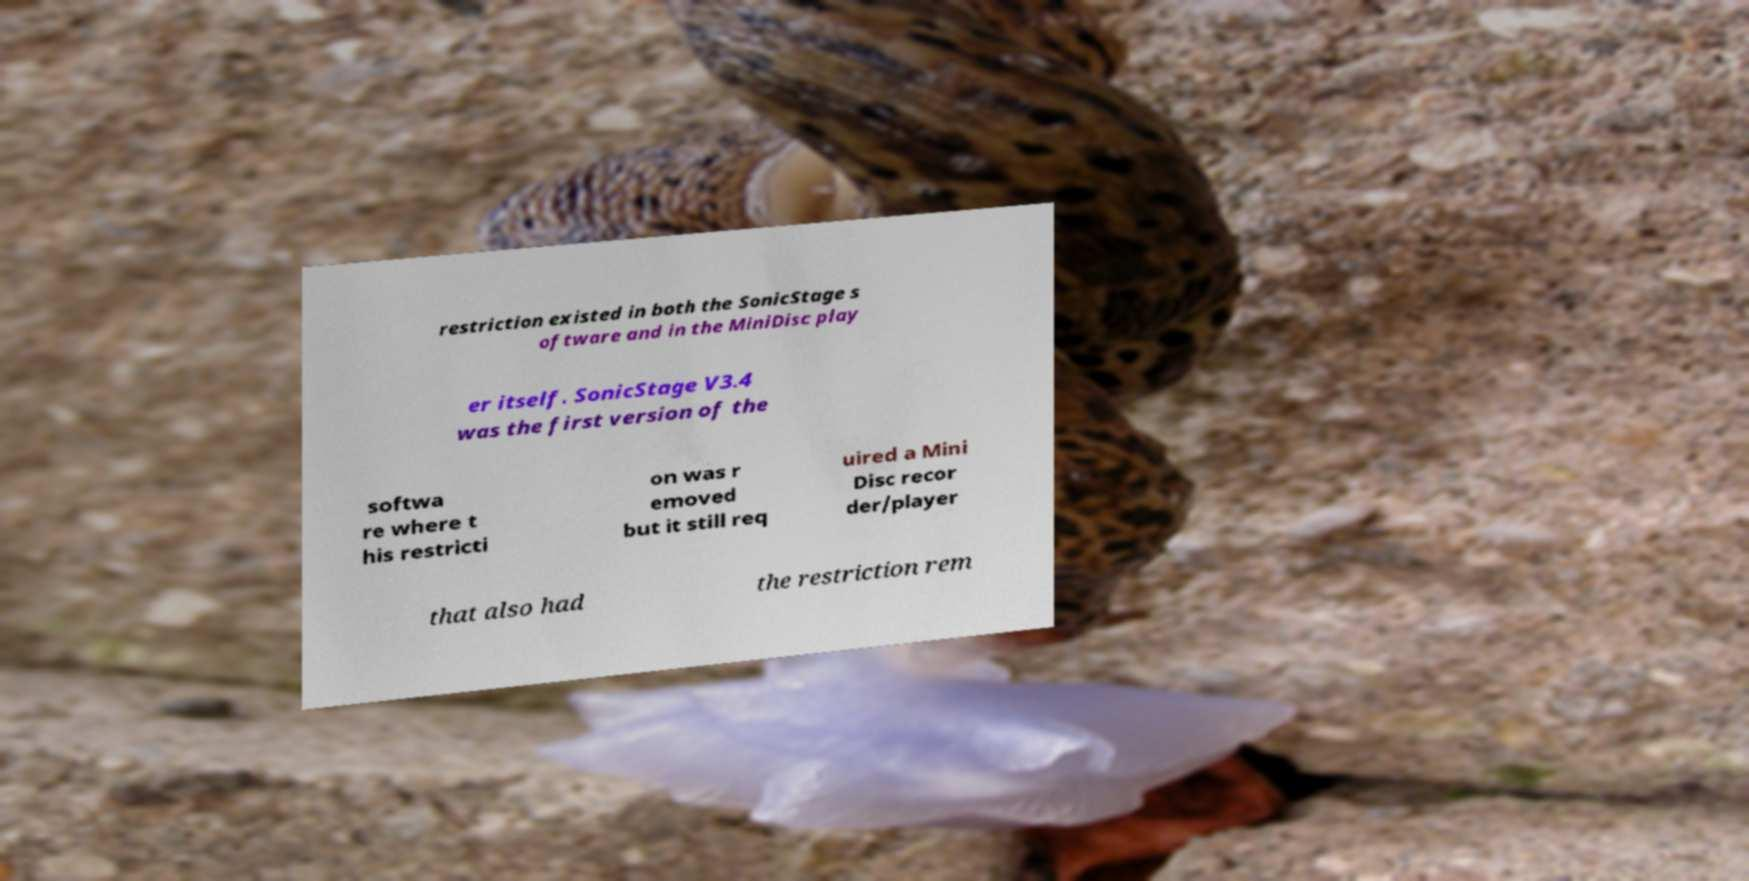Please identify and transcribe the text found in this image. restriction existed in both the SonicStage s oftware and in the MiniDisc play er itself. SonicStage V3.4 was the first version of the softwa re where t his restricti on was r emoved but it still req uired a Mini Disc recor der/player that also had the restriction rem 